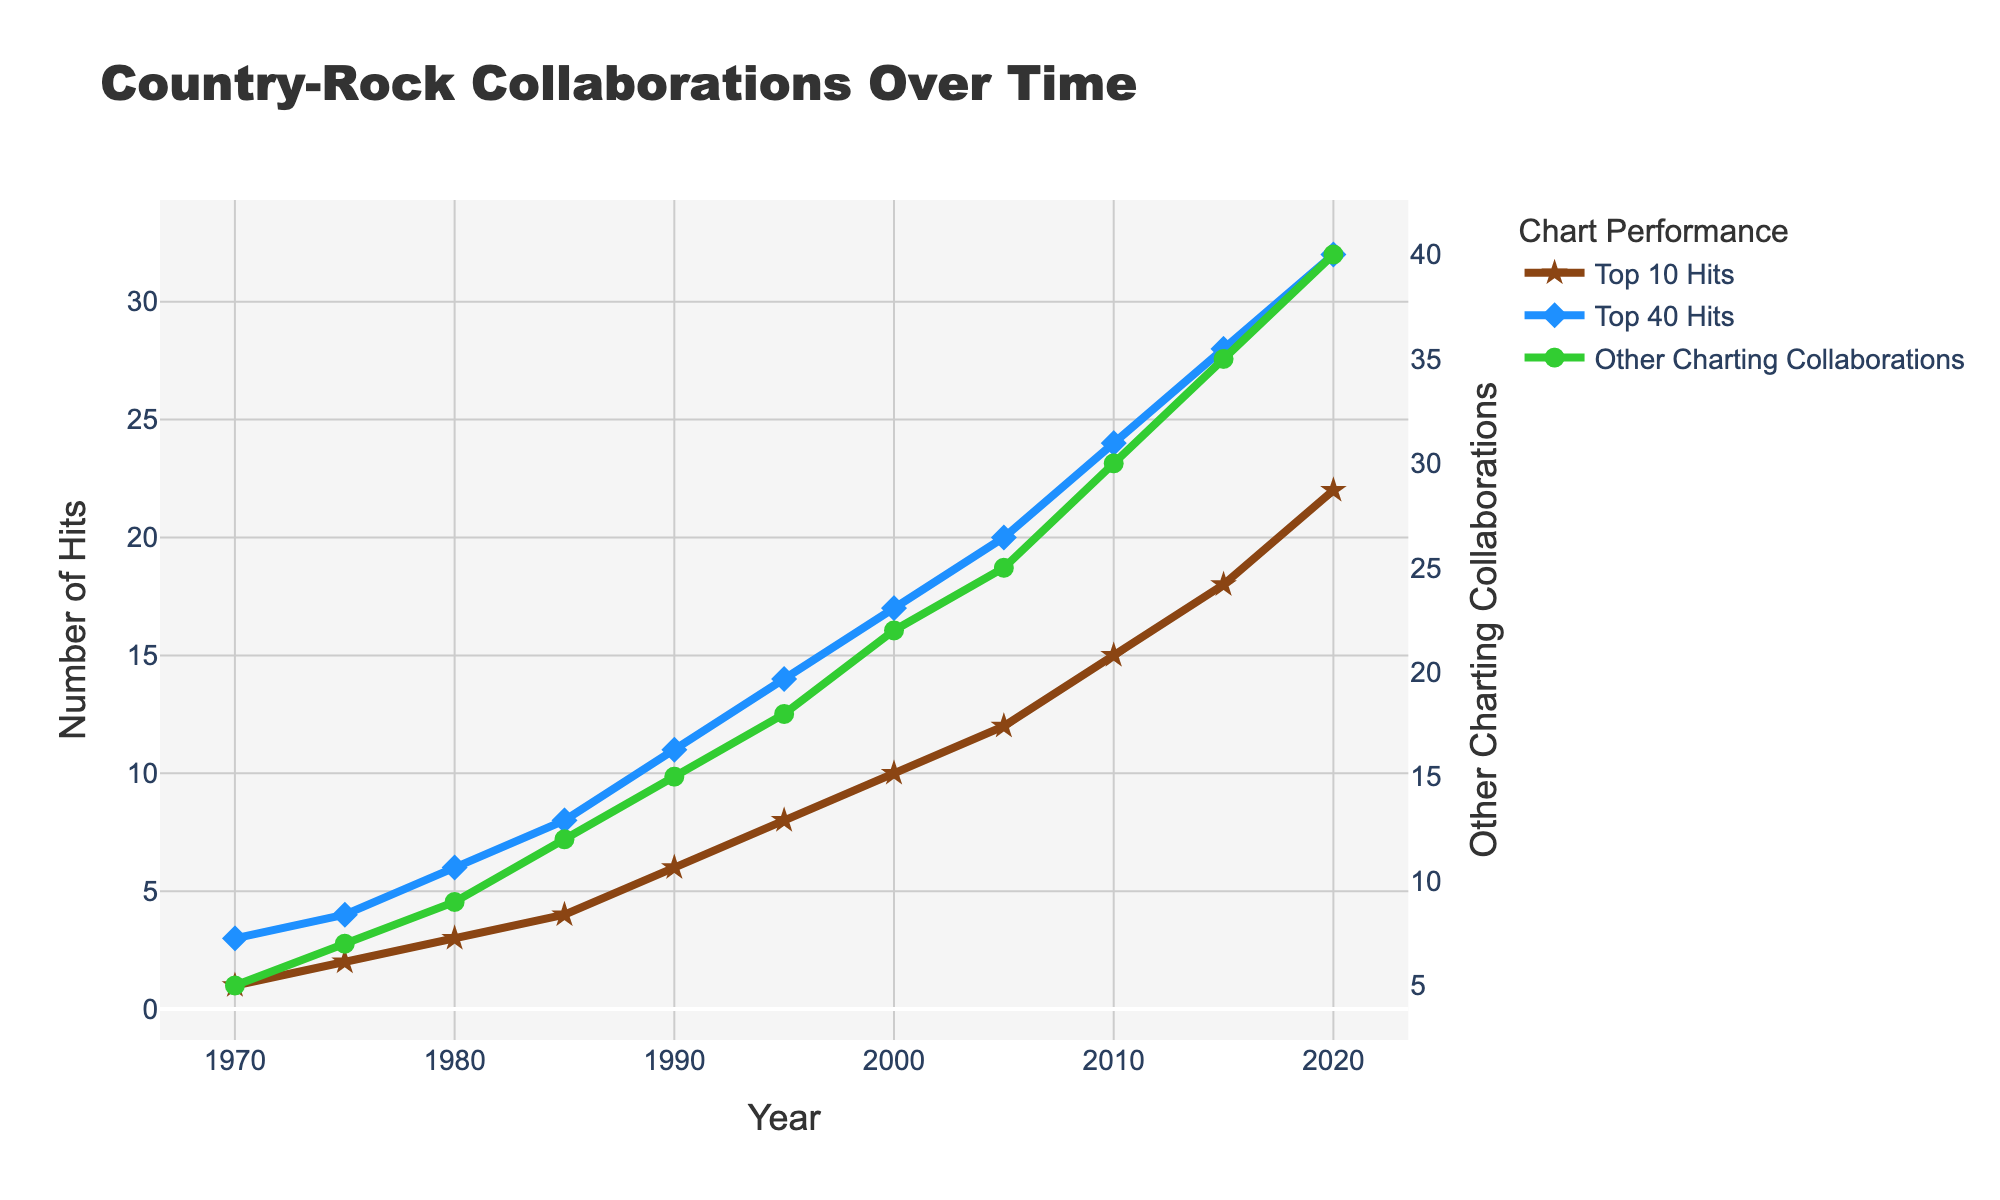What's the trend in the frequency of Top 10 hits collaborations over the past 50 years? Observing the brown line labeled "Top 10 Hits," it consistently increases from 1 in 1970 to 22 in 2020.
Answer: Increasing How does the number of Top 40 hits in 2010 compare to 2000? In 2010, the value for Top 40 Hits (blue line) is 24, while in 2000, it is 17. Therefore, 24 is greater than 17.
Answer: 24 > 17 What's the combined total number of collaborations (Top 10, Top 40, and Other Charting Collaborations) in 1995? Sum up the values for 1995: Top 10 Hits (8), Top 40 Hits (14), and Other Charting Collaborations (18). Adding them together: 8 + 14 + 18 = 40.
Answer: 40 Between which consecutive 5-year periods is the increase in "Other Charting Collaborations" collaborations the highest? Observe the green line's steepest slope between points. Between 2015 and 2020, the increase is from 35 to 40, a change of 5.
Answer: 2015-2020 Which category of collaborations shows the greatest increase from 1970 to 2020? Calculating the increase for each category: 
Top 10 Hits (22 - 1 = 21), 
Top 40 Hits (32 - 3 = 29), 
Other Charting Collaborations (40 - 5 = 35). 
The greatest increase is in Other Charting Collaborations.
Answer: Other Charting Collaborations What's the ratio of Top 40 hits to Top 10 hits in 2005? For 2005, Top 40 Hits is 20 and Top 10 Hits is 12. The ratio is 20/12, which reduces to 5:3.
Answer: 5:3 What visual pattern do you see in the markers used for Top 10 Hits over the years? The markers for Top 10 Hits are brown stars throughout the timeline, indicating consistent use of star markers.
Answer: Brown stars How does the trend in Other Charting Collaborations from 2010 to 2020 compare with the trend in Top 10 Hits during the same period? From 2010 to 2020, the Other Charting Collaborations (green line) increased from 30 to 40, while the Top 10 Hits (brown line) increased from 15 to 22. Both show an increasing trend, but the increase in Other Charting Collaborations (10) is slightly higher compared to Top 10 Hits (7).
Answer: Both increasing, Other Charting Collaborations increase more During which decade did the Top 40 Hits see the fastest growth rate? Assessing the difference in Top 40 Hits values over each decade: 
1970-1980: 6 - 3 = 3 
1980-1990: 11 - 6 = 5 
1990-2000: 17 - 11 = 6 
2000-2010: 24 - 17 = 7 
2010-2020: 32 - 24 = 8.
Thus, the growth rate was the fastest in the decade of 2010-2020.
Answer: 2010-2020 What is the visual effect of using different markers for each category on the readability of the plot? The use of different markers (stars for Top 10 Hits, diamonds for Top 40 Hits, circles for Other Charting Collaborations) helps distinguish the lines easily and enhances readability.
Answer: Enhanced readability 